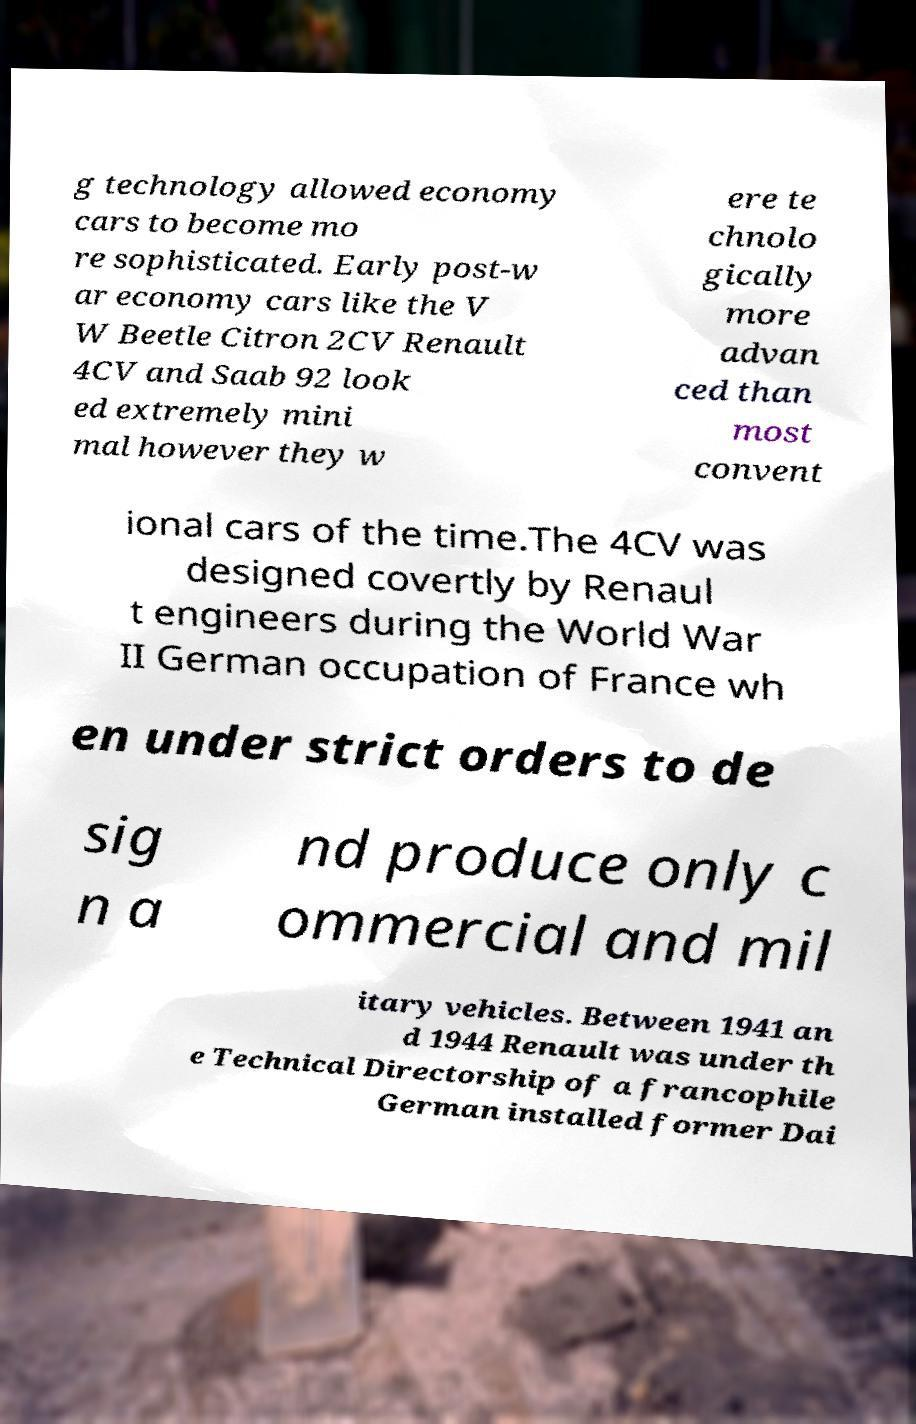Can you read and provide the text displayed in the image?This photo seems to have some interesting text. Can you extract and type it out for me? g technology allowed economy cars to become mo re sophisticated. Early post-w ar economy cars like the V W Beetle Citron 2CV Renault 4CV and Saab 92 look ed extremely mini mal however they w ere te chnolo gically more advan ced than most convent ional cars of the time.The 4CV was designed covertly by Renaul t engineers during the World War II German occupation of France wh en under strict orders to de sig n a nd produce only c ommercial and mil itary vehicles. Between 1941 an d 1944 Renault was under th e Technical Directorship of a francophile German installed former Dai 